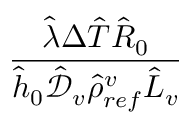Convert formula to latex. <formula><loc_0><loc_0><loc_500><loc_500>\frac { \hat { \lambda } \Delta \hat { T } \hat { R } _ { 0 } } { \hat { h } _ { 0 } \mathcal { \hat { D } } _ { v } \hat { \rho } _ { r e f } ^ { v } \hat { L } _ { v } }</formula> 